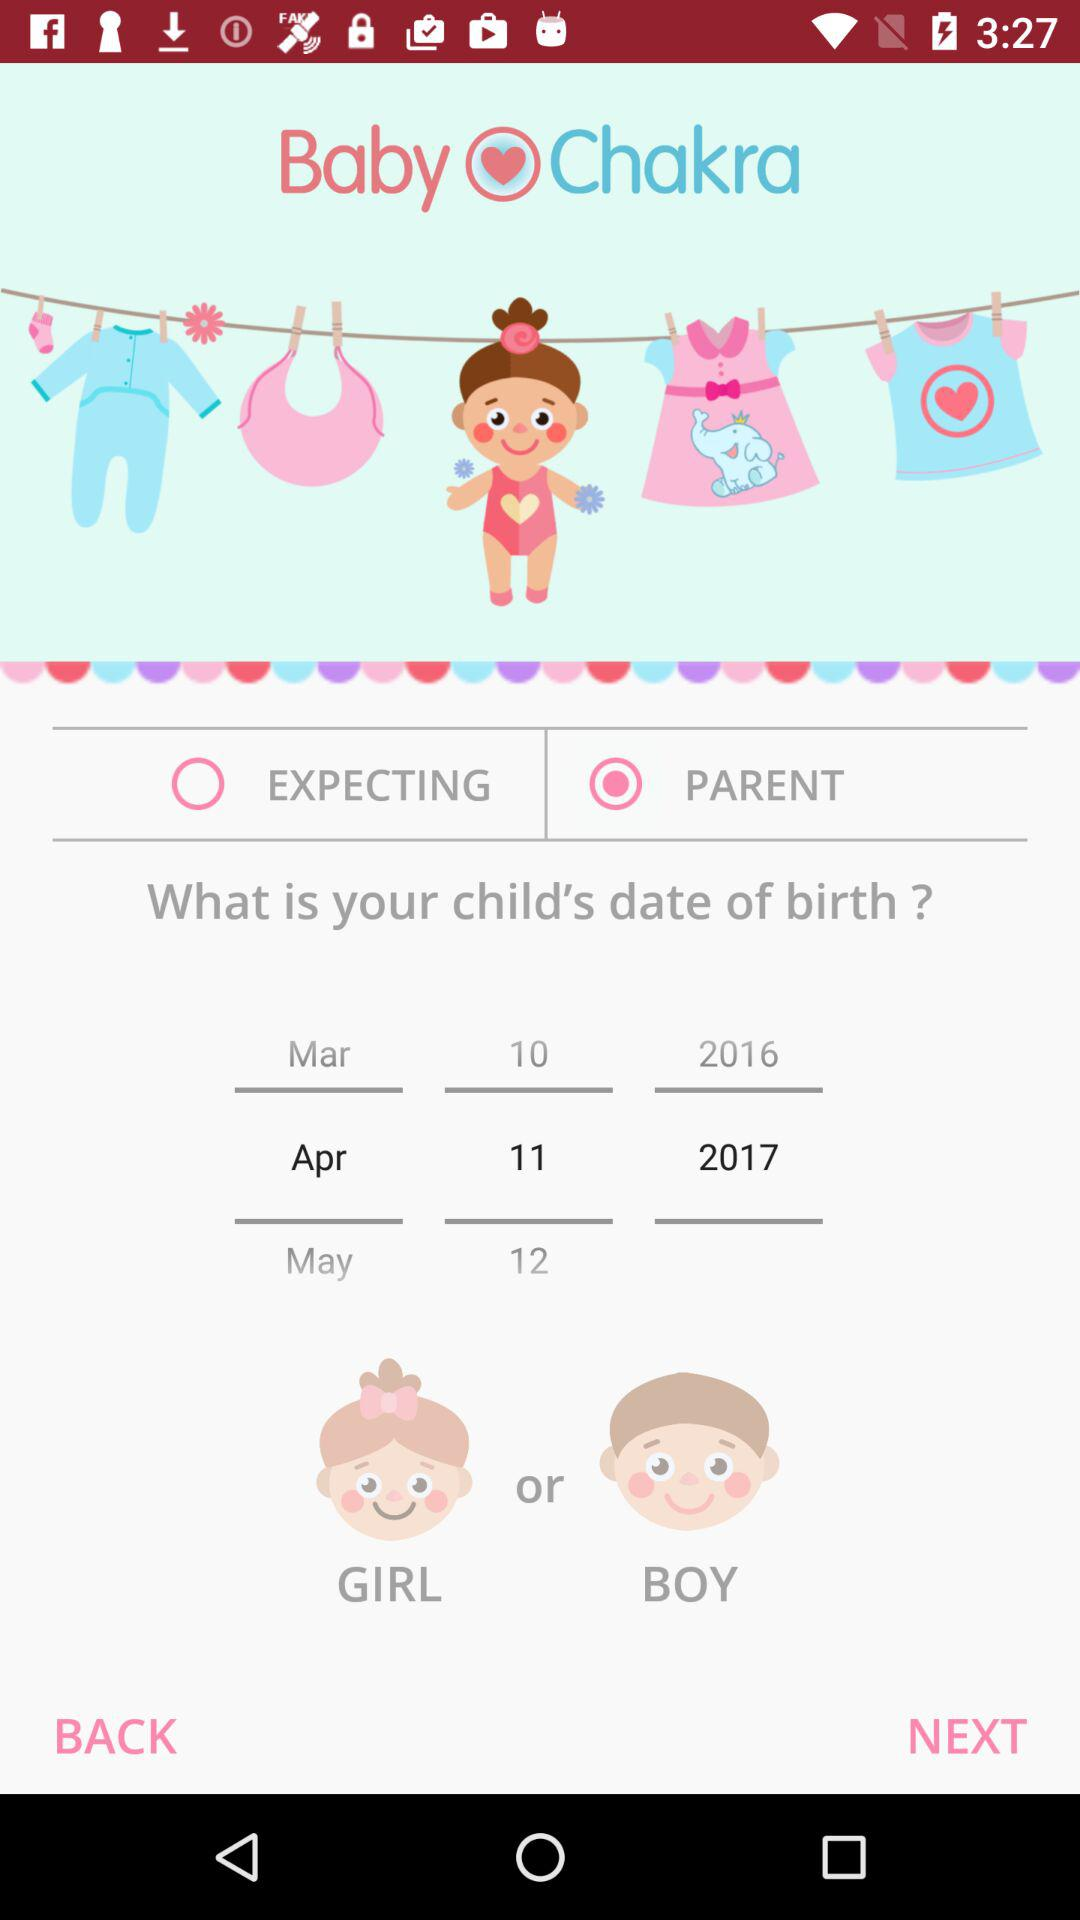How many years are there between the earliest and latest birth dates?
Answer the question using a single word or phrase. 1 